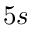Convert formula to latex. <formula><loc_0><loc_0><loc_500><loc_500>5 s</formula> 